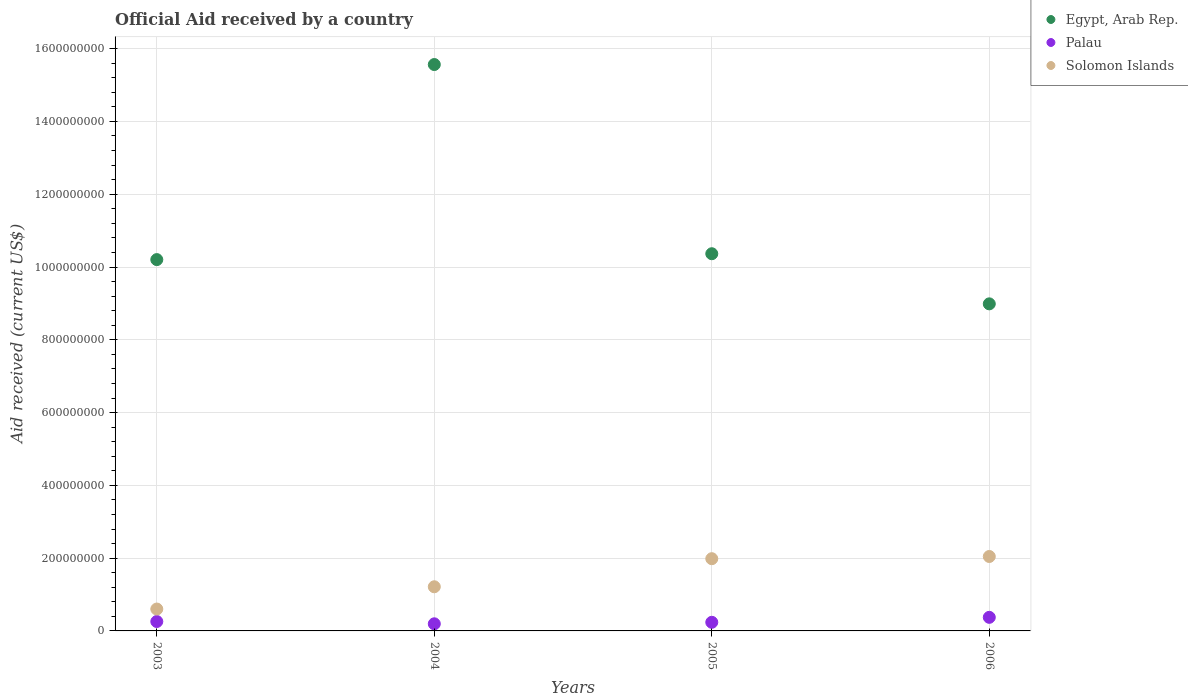How many different coloured dotlines are there?
Ensure brevity in your answer.  3. Is the number of dotlines equal to the number of legend labels?
Offer a very short reply. Yes. What is the net official aid received in Egypt, Arab Rep. in 2004?
Provide a succinct answer. 1.56e+09. Across all years, what is the maximum net official aid received in Solomon Islands?
Keep it short and to the point. 2.05e+08. Across all years, what is the minimum net official aid received in Solomon Islands?
Give a very brief answer. 6.01e+07. What is the total net official aid received in Solomon Islands in the graph?
Offer a terse response. 5.84e+08. What is the difference between the net official aid received in Egypt, Arab Rep. in 2003 and that in 2005?
Make the answer very short. -1.61e+07. What is the difference between the net official aid received in Egypt, Arab Rep. in 2004 and the net official aid received in Solomon Islands in 2005?
Your response must be concise. 1.36e+09. What is the average net official aid received in Palau per year?
Offer a very short reply. 2.66e+07. In the year 2004, what is the difference between the net official aid received in Egypt, Arab Rep. and net official aid received in Palau?
Provide a short and direct response. 1.54e+09. What is the ratio of the net official aid received in Solomon Islands in 2004 to that in 2006?
Provide a short and direct response. 0.59. Is the net official aid received in Solomon Islands in 2004 less than that in 2005?
Offer a terse response. Yes. What is the difference between the highest and the second highest net official aid received in Solomon Islands?
Ensure brevity in your answer.  6.04e+06. What is the difference between the highest and the lowest net official aid received in Palau?
Ensure brevity in your answer.  1.78e+07. Is it the case that in every year, the sum of the net official aid received in Egypt, Arab Rep. and net official aid received in Solomon Islands  is greater than the net official aid received in Palau?
Offer a terse response. Yes. Is the net official aid received in Egypt, Arab Rep. strictly less than the net official aid received in Solomon Islands over the years?
Keep it short and to the point. No. How many years are there in the graph?
Provide a short and direct response. 4. Does the graph contain any zero values?
Keep it short and to the point. No. Does the graph contain grids?
Offer a very short reply. Yes. Where does the legend appear in the graph?
Your answer should be very brief. Top right. What is the title of the graph?
Your answer should be very brief. Official Aid received by a country. What is the label or title of the X-axis?
Offer a terse response. Years. What is the label or title of the Y-axis?
Offer a terse response. Aid received (current US$). What is the Aid received (current US$) in Egypt, Arab Rep. in 2003?
Offer a very short reply. 1.02e+09. What is the Aid received (current US$) of Palau in 2003?
Keep it short and to the point. 2.58e+07. What is the Aid received (current US$) of Solomon Islands in 2003?
Keep it short and to the point. 6.01e+07. What is the Aid received (current US$) in Egypt, Arab Rep. in 2004?
Offer a very short reply. 1.56e+09. What is the Aid received (current US$) of Palau in 2004?
Make the answer very short. 1.96e+07. What is the Aid received (current US$) of Solomon Islands in 2004?
Your answer should be very brief. 1.21e+08. What is the Aid received (current US$) in Egypt, Arab Rep. in 2005?
Offer a terse response. 1.04e+09. What is the Aid received (current US$) of Palau in 2005?
Provide a short and direct response. 2.37e+07. What is the Aid received (current US$) of Solomon Islands in 2005?
Your answer should be very brief. 1.98e+08. What is the Aid received (current US$) in Egypt, Arab Rep. in 2006?
Ensure brevity in your answer.  8.99e+08. What is the Aid received (current US$) of Palau in 2006?
Ensure brevity in your answer.  3.73e+07. What is the Aid received (current US$) in Solomon Islands in 2006?
Offer a very short reply. 2.05e+08. Across all years, what is the maximum Aid received (current US$) of Egypt, Arab Rep.?
Give a very brief answer. 1.56e+09. Across all years, what is the maximum Aid received (current US$) in Palau?
Make the answer very short. 3.73e+07. Across all years, what is the maximum Aid received (current US$) of Solomon Islands?
Give a very brief answer. 2.05e+08. Across all years, what is the minimum Aid received (current US$) in Egypt, Arab Rep.?
Offer a very short reply. 8.99e+08. Across all years, what is the minimum Aid received (current US$) of Palau?
Ensure brevity in your answer.  1.96e+07. Across all years, what is the minimum Aid received (current US$) of Solomon Islands?
Keep it short and to the point. 6.01e+07. What is the total Aid received (current US$) of Egypt, Arab Rep. in the graph?
Provide a succinct answer. 4.51e+09. What is the total Aid received (current US$) in Palau in the graph?
Provide a succinct answer. 1.06e+08. What is the total Aid received (current US$) in Solomon Islands in the graph?
Offer a terse response. 5.84e+08. What is the difference between the Aid received (current US$) in Egypt, Arab Rep. in 2003 and that in 2004?
Offer a very short reply. -5.36e+08. What is the difference between the Aid received (current US$) in Palau in 2003 and that in 2004?
Keep it short and to the point. 6.30e+06. What is the difference between the Aid received (current US$) in Solomon Islands in 2003 and that in 2004?
Ensure brevity in your answer.  -6.12e+07. What is the difference between the Aid received (current US$) in Egypt, Arab Rep. in 2003 and that in 2005?
Give a very brief answer. -1.61e+07. What is the difference between the Aid received (current US$) of Palau in 2003 and that in 2005?
Offer a terse response. 2.16e+06. What is the difference between the Aid received (current US$) of Solomon Islands in 2003 and that in 2005?
Your response must be concise. -1.38e+08. What is the difference between the Aid received (current US$) of Egypt, Arab Rep. in 2003 and that in 2006?
Ensure brevity in your answer.  1.22e+08. What is the difference between the Aid received (current US$) of Palau in 2003 and that in 2006?
Offer a very short reply. -1.15e+07. What is the difference between the Aid received (current US$) of Solomon Islands in 2003 and that in 2006?
Ensure brevity in your answer.  -1.44e+08. What is the difference between the Aid received (current US$) of Egypt, Arab Rep. in 2004 and that in 2005?
Provide a succinct answer. 5.20e+08. What is the difference between the Aid received (current US$) in Palau in 2004 and that in 2005?
Make the answer very short. -4.14e+06. What is the difference between the Aid received (current US$) of Solomon Islands in 2004 and that in 2005?
Make the answer very short. -7.72e+07. What is the difference between the Aid received (current US$) of Egypt, Arab Rep. in 2004 and that in 2006?
Your answer should be very brief. 6.58e+08. What is the difference between the Aid received (current US$) in Palau in 2004 and that in 2006?
Your answer should be compact. -1.78e+07. What is the difference between the Aid received (current US$) of Solomon Islands in 2004 and that in 2006?
Give a very brief answer. -8.32e+07. What is the difference between the Aid received (current US$) in Egypt, Arab Rep. in 2005 and that in 2006?
Provide a succinct answer. 1.38e+08. What is the difference between the Aid received (current US$) of Palau in 2005 and that in 2006?
Your response must be concise. -1.36e+07. What is the difference between the Aid received (current US$) in Solomon Islands in 2005 and that in 2006?
Offer a very short reply. -6.04e+06. What is the difference between the Aid received (current US$) in Egypt, Arab Rep. in 2003 and the Aid received (current US$) in Palau in 2004?
Offer a very short reply. 1.00e+09. What is the difference between the Aid received (current US$) in Egypt, Arab Rep. in 2003 and the Aid received (current US$) in Solomon Islands in 2004?
Offer a very short reply. 8.99e+08. What is the difference between the Aid received (current US$) in Palau in 2003 and the Aid received (current US$) in Solomon Islands in 2004?
Keep it short and to the point. -9.55e+07. What is the difference between the Aid received (current US$) of Egypt, Arab Rep. in 2003 and the Aid received (current US$) of Palau in 2005?
Make the answer very short. 9.97e+08. What is the difference between the Aid received (current US$) of Egypt, Arab Rep. in 2003 and the Aid received (current US$) of Solomon Islands in 2005?
Make the answer very short. 8.22e+08. What is the difference between the Aid received (current US$) in Palau in 2003 and the Aid received (current US$) in Solomon Islands in 2005?
Ensure brevity in your answer.  -1.73e+08. What is the difference between the Aid received (current US$) in Egypt, Arab Rep. in 2003 and the Aid received (current US$) in Palau in 2006?
Provide a succinct answer. 9.83e+08. What is the difference between the Aid received (current US$) in Egypt, Arab Rep. in 2003 and the Aid received (current US$) in Solomon Islands in 2006?
Your answer should be very brief. 8.16e+08. What is the difference between the Aid received (current US$) of Palau in 2003 and the Aid received (current US$) of Solomon Islands in 2006?
Offer a very short reply. -1.79e+08. What is the difference between the Aid received (current US$) in Egypt, Arab Rep. in 2004 and the Aid received (current US$) in Palau in 2005?
Ensure brevity in your answer.  1.53e+09. What is the difference between the Aid received (current US$) in Egypt, Arab Rep. in 2004 and the Aid received (current US$) in Solomon Islands in 2005?
Offer a terse response. 1.36e+09. What is the difference between the Aid received (current US$) in Palau in 2004 and the Aid received (current US$) in Solomon Islands in 2005?
Offer a very short reply. -1.79e+08. What is the difference between the Aid received (current US$) of Egypt, Arab Rep. in 2004 and the Aid received (current US$) of Palau in 2006?
Your answer should be very brief. 1.52e+09. What is the difference between the Aid received (current US$) in Egypt, Arab Rep. in 2004 and the Aid received (current US$) in Solomon Islands in 2006?
Keep it short and to the point. 1.35e+09. What is the difference between the Aid received (current US$) in Palau in 2004 and the Aid received (current US$) in Solomon Islands in 2006?
Keep it short and to the point. -1.85e+08. What is the difference between the Aid received (current US$) in Egypt, Arab Rep. in 2005 and the Aid received (current US$) in Palau in 2006?
Your answer should be compact. 9.99e+08. What is the difference between the Aid received (current US$) of Egypt, Arab Rep. in 2005 and the Aid received (current US$) of Solomon Islands in 2006?
Make the answer very short. 8.32e+08. What is the difference between the Aid received (current US$) in Palau in 2005 and the Aid received (current US$) in Solomon Islands in 2006?
Provide a short and direct response. -1.81e+08. What is the average Aid received (current US$) in Egypt, Arab Rep. per year?
Provide a short and direct response. 1.13e+09. What is the average Aid received (current US$) in Palau per year?
Provide a succinct answer. 2.66e+07. What is the average Aid received (current US$) in Solomon Islands per year?
Give a very brief answer. 1.46e+08. In the year 2003, what is the difference between the Aid received (current US$) in Egypt, Arab Rep. and Aid received (current US$) in Palau?
Offer a very short reply. 9.94e+08. In the year 2003, what is the difference between the Aid received (current US$) of Egypt, Arab Rep. and Aid received (current US$) of Solomon Islands?
Offer a very short reply. 9.60e+08. In the year 2003, what is the difference between the Aid received (current US$) of Palau and Aid received (current US$) of Solomon Islands?
Provide a succinct answer. -3.43e+07. In the year 2004, what is the difference between the Aid received (current US$) in Egypt, Arab Rep. and Aid received (current US$) in Palau?
Keep it short and to the point. 1.54e+09. In the year 2004, what is the difference between the Aid received (current US$) of Egypt, Arab Rep. and Aid received (current US$) of Solomon Islands?
Provide a short and direct response. 1.44e+09. In the year 2004, what is the difference between the Aid received (current US$) of Palau and Aid received (current US$) of Solomon Islands?
Your answer should be very brief. -1.02e+08. In the year 2005, what is the difference between the Aid received (current US$) of Egypt, Arab Rep. and Aid received (current US$) of Palau?
Keep it short and to the point. 1.01e+09. In the year 2005, what is the difference between the Aid received (current US$) of Egypt, Arab Rep. and Aid received (current US$) of Solomon Islands?
Your answer should be compact. 8.38e+08. In the year 2005, what is the difference between the Aid received (current US$) in Palau and Aid received (current US$) in Solomon Islands?
Your answer should be very brief. -1.75e+08. In the year 2006, what is the difference between the Aid received (current US$) in Egypt, Arab Rep. and Aid received (current US$) in Palau?
Ensure brevity in your answer.  8.61e+08. In the year 2006, what is the difference between the Aid received (current US$) of Egypt, Arab Rep. and Aid received (current US$) of Solomon Islands?
Provide a succinct answer. 6.94e+08. In the year 2006, what is the difference between the Aid received (current US$) in Palau and Aid received (current US$) in Solomon Islands?
Provide a short and direct response. -1.67e+08. What is the ratio of the Aid received (current US$) in Egypt, Arab Rep. in 2003 to that in 2004?
Ensure brevity in your answer.  0.66. What is the ratio of the Aid received (current US$) of Palau in 2003 to that in 2004?
Your answer should be compact. 1.32. What is the ratio of the Aid received (current US$) in Solomon Islands in 2003 to that in 2004?
Your answer should be compact. 0.5. What is the ratio of the Aid received (current US$) in Egypt, Arab Rep. in 2003 to that in 2005?
Your response must be concise. 0.98. What is the ratio of the Aid received (current US$) of Palau in 2003 to that in 2005?
Keep it short and to the point. 1.09. What is the ratio of the Aid received (current US$) of Solomon Islands in 2003 to that in 2005?
Offer a very short reply. 0.3. What is the ratio of the Aid received (current US$) in Egypt, Arab Rep. in 2003 to that in 2006?
Provide a short and direct response. 1.14. What is the ratio of the Aid received (current US$) of Palau in 2003 to that in 2006?
Give a very brief answer. 0.69. What is the ratio of the Aid received (current US$) of Solomon Islands in 2003 to that in 2006?
Provide a succinct answer. 0.29. What is the ratio of the Aid received (current US$) in Egypt, Arab Rep. in 2004 to that in 2005?
Offer a very short reply. 1.5. What is the ratio of the Aid received (current US$) of Palau in 2004 to that in 2005?
Your answer should be very brief. 0.83. What is the ratio of the Aid received (current US$) of Solomon Islands in 2004 to that in 2005?
Your answer should be very brief. 0.61. What is the ratio of the Aid received (current US$) of Egypt, Arab Rep. in 2004 to that in 2006?
Make the answer very short. 1.73. What is the ratio of the Aid received (current US$) in Palau in 2004 to that in 2006?
Ensure brevity in your answer.  0.52. What is the ratio of the Aid received (current US$) in Solomon Islands in 2004 to that in 2006?
Your answer should be very brief. 0.59. What is the ratio of the Aid received (current US$) of Egypt, Arab Rep. in 2005 to that in 2006?
Make the answer very short. 1.15. What is the ratio of the Aid received (current US$) of Palau in 2005 to that in 2006?
Keep it short and to the point. 0.63. What is the ratio of the Aid received (current US$) in Solomon Islands in 2005 to that in 2006?
Keep it short and to the point. 0.97. What is the difference between the highest and the second highest Aid received (current US$) in Egypt, Arab Rep.?
Ensure brevity in your answer.  5.20e+08. What is the difference between the highest and the second highest Aid received (current US$) in Palau?
Offer a terse response. 1.15e+07. What is the difference between the highest and the second highest Aid received (current US$) of Solomon Islands?
Keep it short and to the point. 6.04e+06. What is the difference between the highest and the lowest Aid received (current US$) in Egypt, Arab Rep.?
Offer a very short reply. 6.58e+08. What is the difference between the highest and the lowest Aid received (current US$) in Palau?
Your answer should be compact. 1.78e+07. What is the difference between the highest and the lowest Aid received (current US$) in Solomon Islands?
Provide a short and direct response. 1.44e+08. 